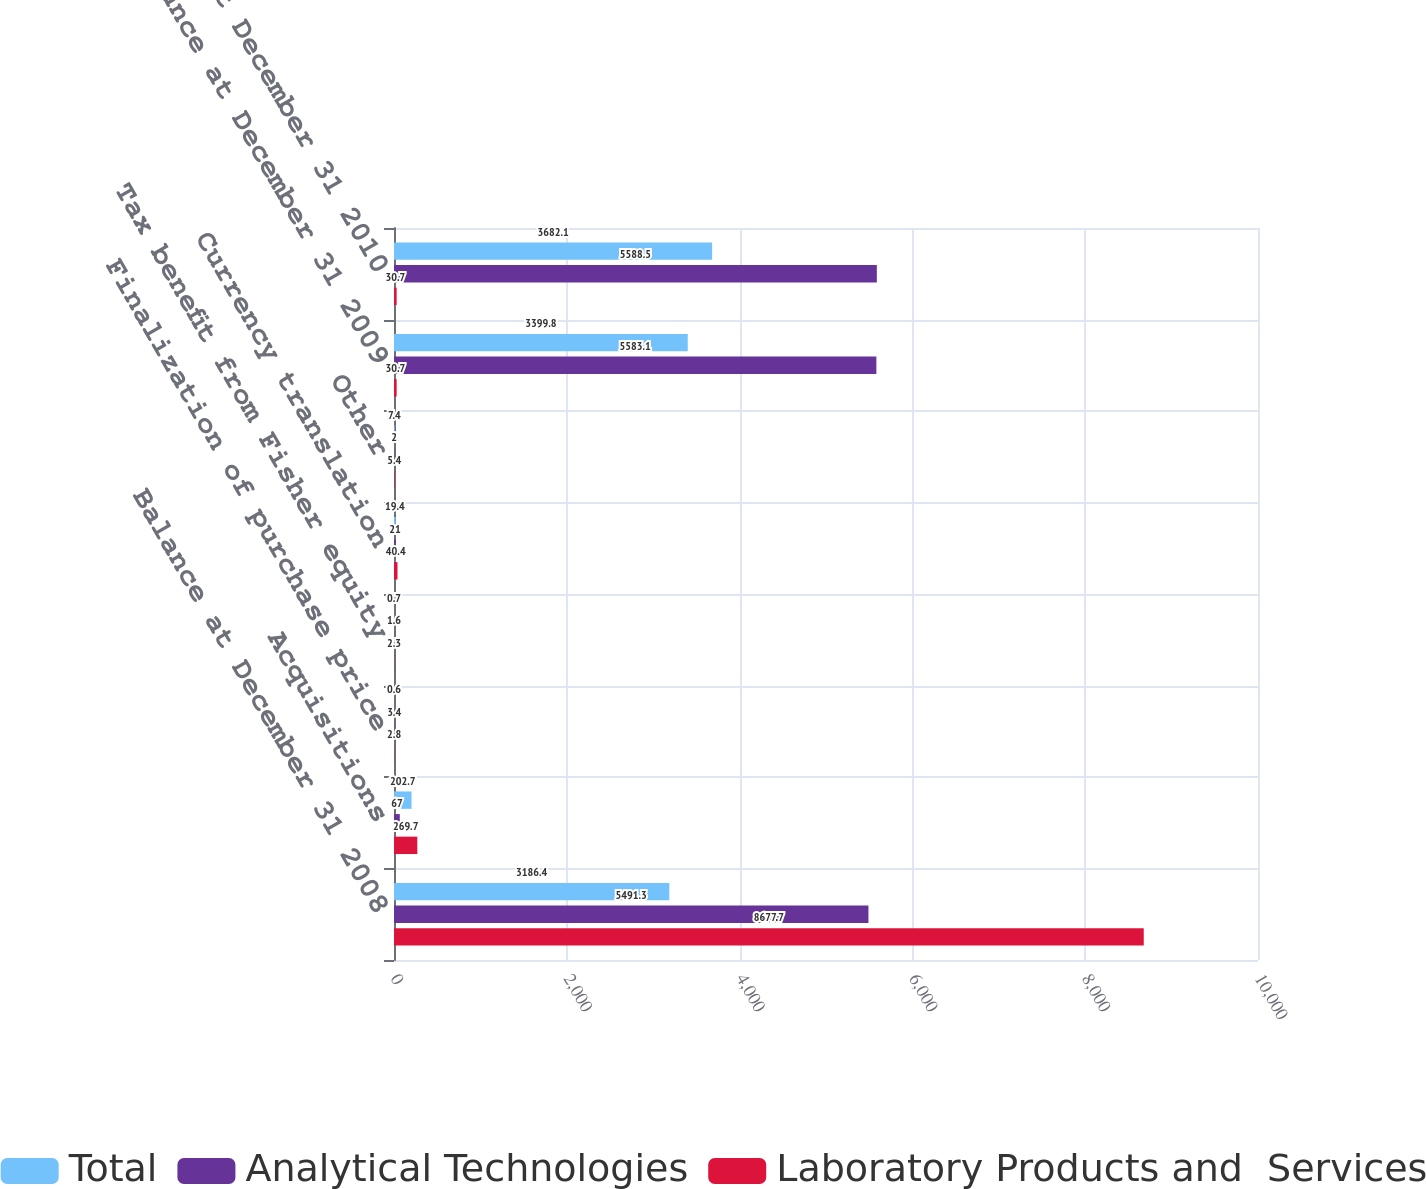<chart> <loc_0><loc_0><loc_500><loc_500><stacked_bar_chart><ecel><fcel>Balance at December 31 2008<fcel>Acquisitions<fcel>Finalization of purchase price<fcel>Tax benefit from Fisher equity<fcel>Currency translation<fcel>Other<fcel>Balance at December 31 2009<fcel>Balance at December 31 2010<nl><fcel>Total<fcel>3186.4<fcel>202.7<fcel>0.6<fcel>0.7<fcel>19.4<fcel>7.4<fcel>3399.8<fcel>3682.1<nl><fcel>Analytical Technologies<fcel>5491.3<fcel>67<fcel>3.4<fcel>1.6<fcel>21<fcel>2<fcel>5583.1<fcel>5588.5<nl><fcel>Laboratory Products and  Services<fcel>8677.7<fcel>269.7<fcel>2.8<fcel>2.3<fcel>40.4<fcel>5.4<fcel>30.7<fcel>30.7<nl></chart> 